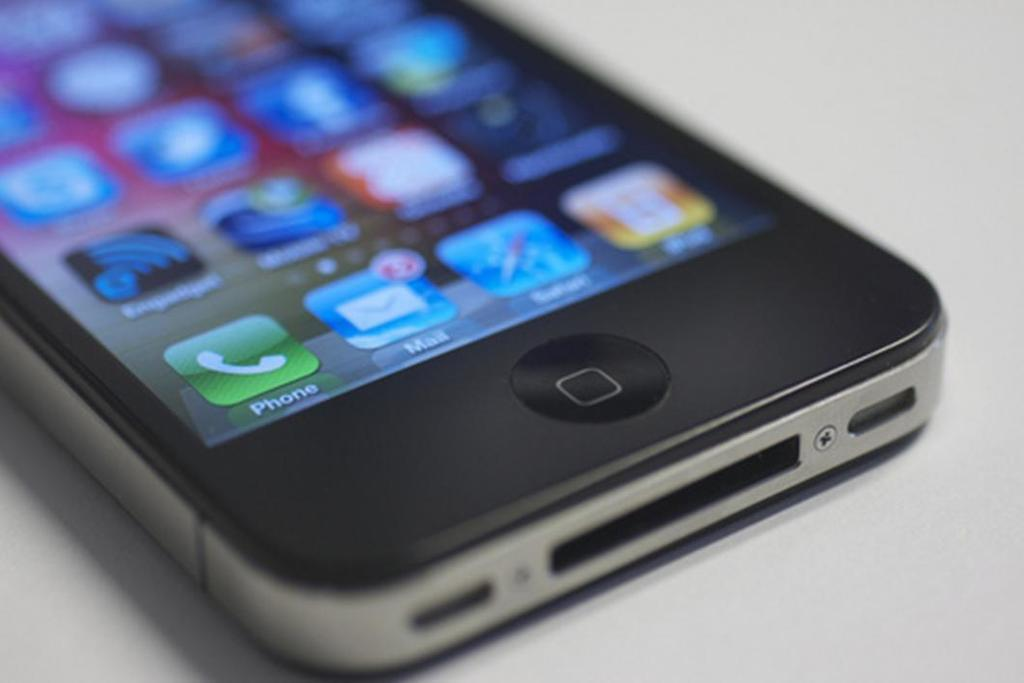<image>
Summarize the visual content of the image. A green Phone icon is on the phone 